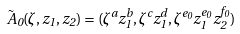<formula> <loc_0><loc_0><loc_500><loc_500>\tilde { A } _ { 0 } ( \zeta , z _ { 1 } , z _ { 2 } ) = ( \zeta ^ { a } z _ { 1 } ^ { b } , \zeta ^ { c } z _ { 1 } ^ { d } , \zeta ^ { e _ { 0 } } z _ { 1 } ^ { e _ { 0 } } z _ { 2 } ^ { f _ { 0 } } )</formula> 